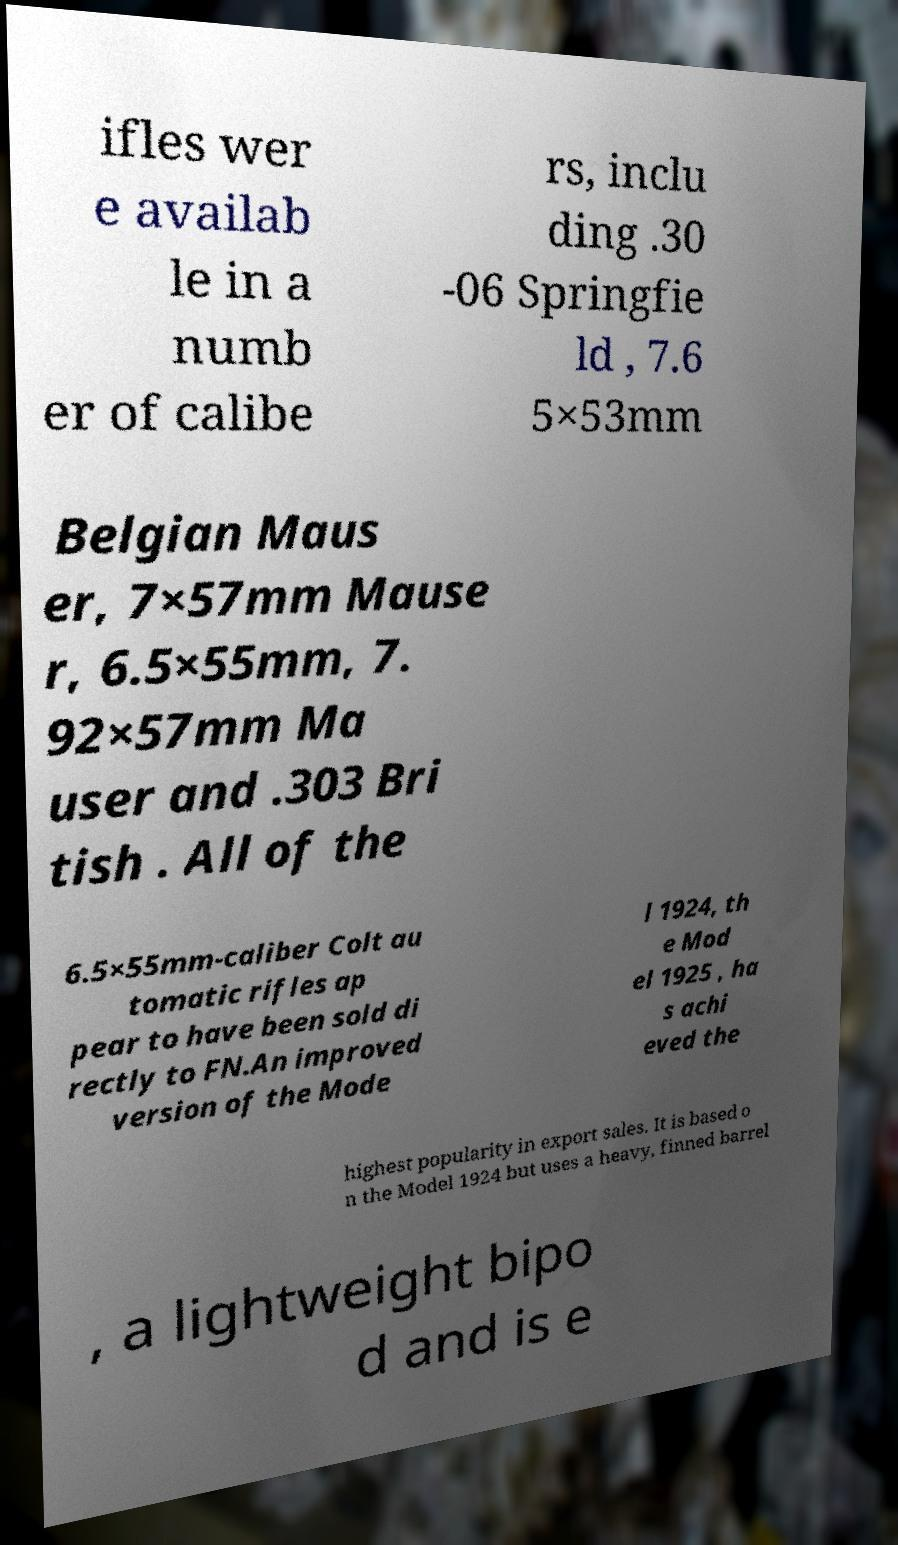Can you accurately transcribe the text from the provided image for me? ifles wer e availab le in a numb er of calibe rs, inclu ding .30 -06 Springfie ld , 7.6 5×53mm Belgian Maus er, 7×57mm Mause r, 6.5×55mm, 7. 92×57mm Ma user and .303 Bri tish . All of the 6.5×55mm-caliber Colt au tomatic rifles ap pear to have been sold di rectly to FN.An improved version of the Mode l 1924, th e Mod el 1925 , ha s achi eved the highest popularity in export sales. It is based o n the Model 1924 but uses a heavy, finned barrel , a lightweight bipo d and is e 